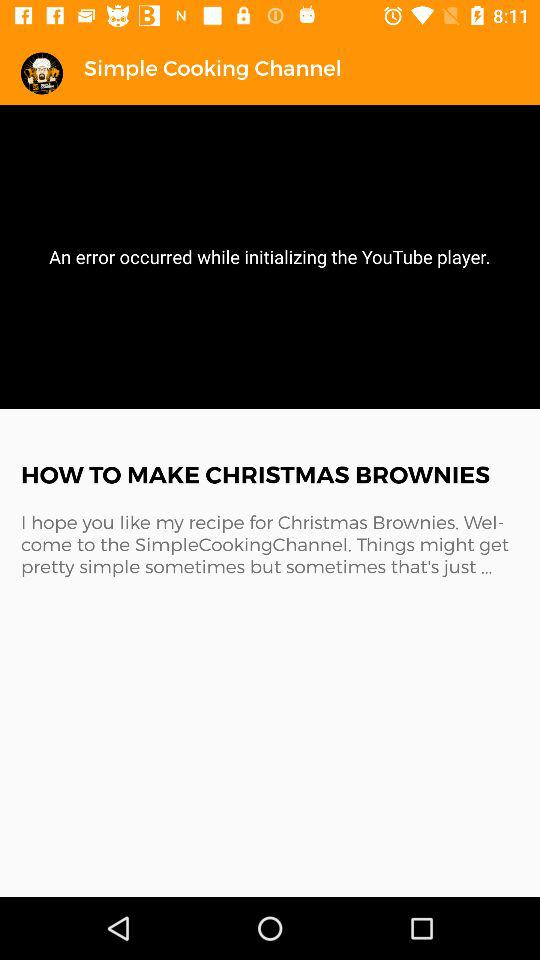What is the name of the channel? The name of the channel is Simple Cooking. 